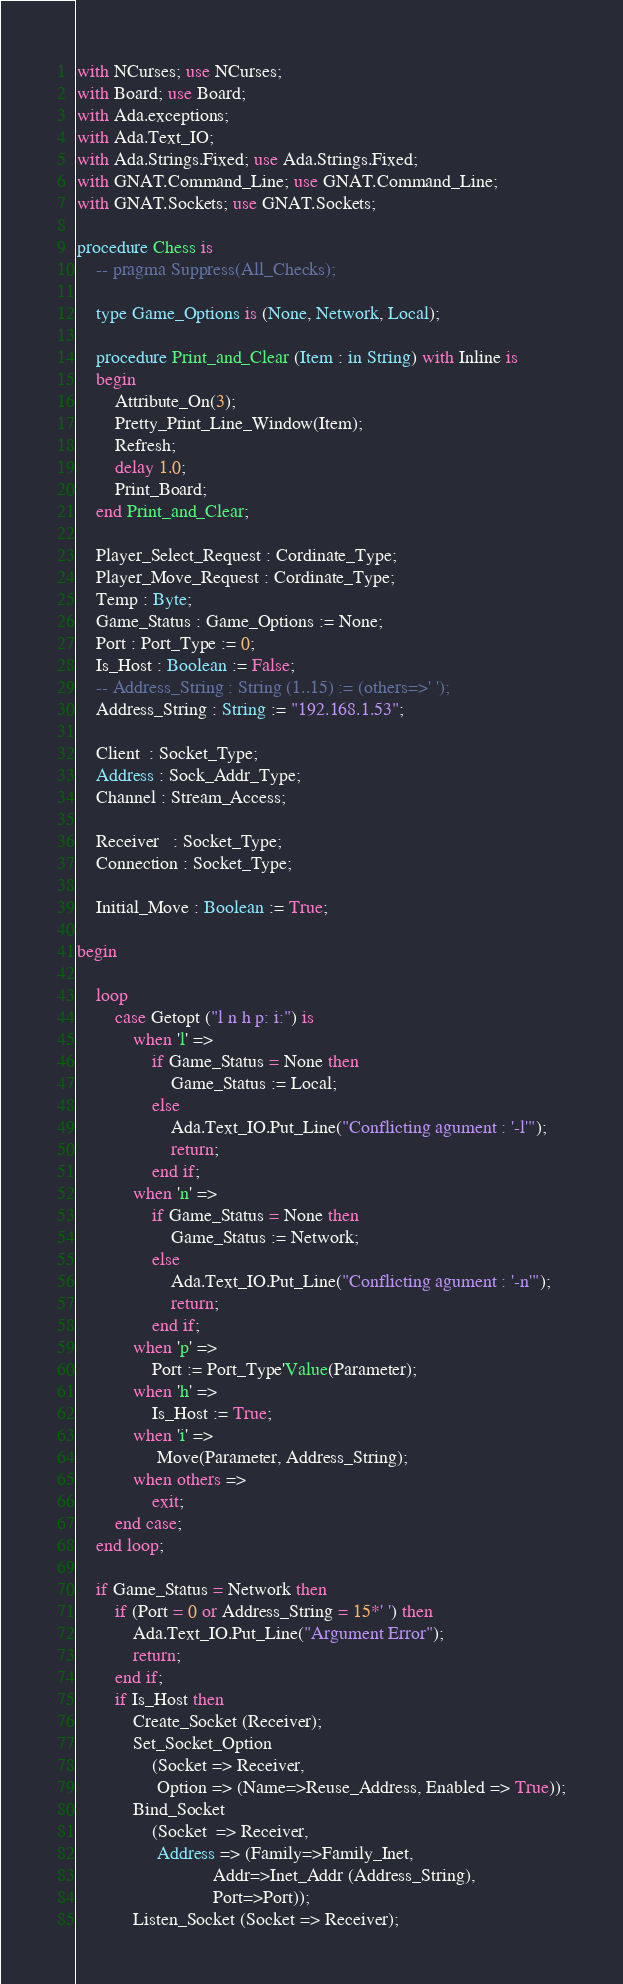<code> <loc_0><loc_0><loc_500><loc_500><_Ada_>with NCurses; use NCurses;
with Board; use Board;
with Ada.exceptions;
with Ada.Text_IO;
with Ada.Strings.Fixed; use Ada.Strings.Fixed;
with GNAT.Command_Line; use GNAT.Command_Line;
with GNAT.Sockets; use GNAT.Sockets;

procedure Chess is
	-- pragma Suppress(All_Checks);

	type Game_Options is (None, Network, Local);

	procedure Print_and_Clear (Item : in String) with Inline is
	begin
		Attribute_On(3);
		Pretty_Print_Line_Window(Item);
		Refresh;
		delay 1.0;
		Print_Board;
	end Print_and_Clear;

	Player_Select_Request : Cordinate_Type;
	Player_Move_Request : Cordinate_Type;
	Temp : Byte;
	Game_Status : Game_Options := None;
	Port : Port_Type := 0;
	Is_Host : Boolean := False;
	-- Address_String : String (1..15) := (others=>' ');
	Address_String : String := "192.168.1.53";

	Client  : Socket_Type;
	Address : Sock_Addr_Type;
	Channel : Stream_Access; 

	Receiver   : Socket_Type;
	Connection : Socket_Type;

	Initial_Move : Boolean := True;

begin

	loop
		case Getopt ("l n h p: i:") is
			when 'l' =>
				if Game_Status = None then
					Game_Status := Local;
				else
					Ada.Text_IO.Put_Line("Conflicting agument : '-l'");
					return;
				end if;
			when 'n' =>
				if Game_Status = None then
					Game_Status := Network;
				else
					Ada.Text_IO.Put_Line("Conflicting agument : '-n'");
					return;
				end if;
			when 'p' =>
				Port := Port_Type'Value(Parameter);
			when 'h' =>
				Is_Host := True;
			when 'i' =>
				 Move(Parameter, Address_String);
			when others =>
				exit;
		end case;
	end loop;

	if Game_Status = Network then
		if (Port = 0 or Address_String = 15*' ') then
			Ada.Text_IO.Put_Line("Argument Error");
			return;
		end if;
		if Is_Host then
			Create_Socket (Receiver);
			Set_Socket_Option
				(Socket => Receiver,
				 Option => (Name=>Reuse_Address, Enabled => True));
			Bind_Socket
				(Socket  => Receiver,
				 Address => (Family=>Family_Inet,
							 Addr=>Inet_Addr (Address_String),
							 Port=>Port));
			Listen_Socket (Socket => Receiver);</code> 